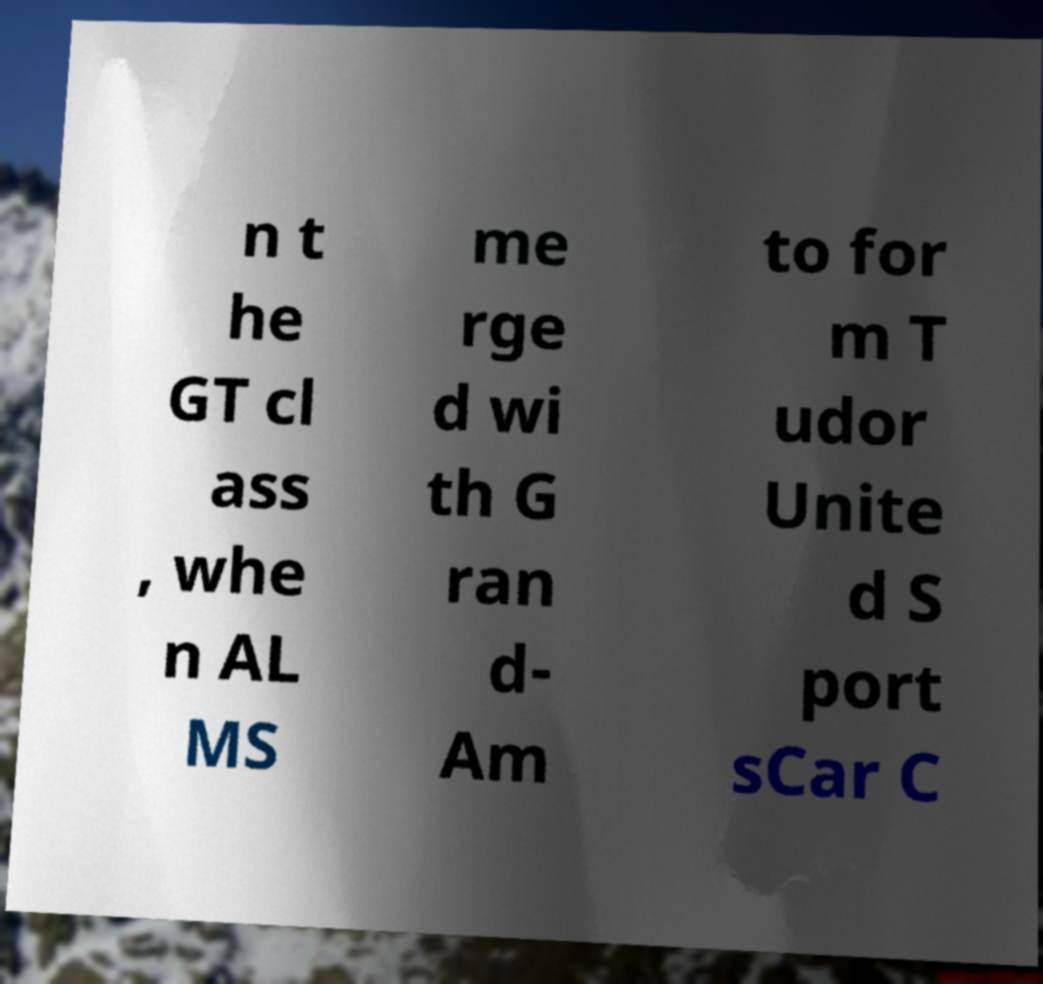For documentation purposes, I need the text within this image transcribed. Could you provide that? n t he GT cl ass , whe n AL MS me rge d wi th G ran d- Am to for m T udor Unite d S port sCar C 